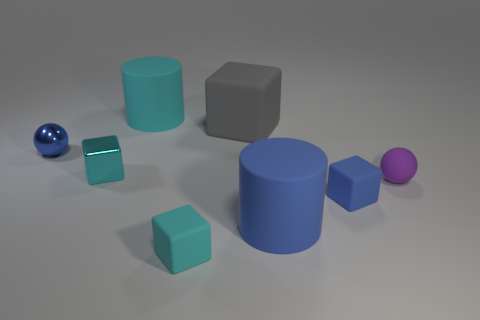Subtract all small cyan rubber cubes. How many cubes are left? 3 Subtract all purple spheres. How many spheres are left? 1 Add 1 purple metallic cylinders. How many objects exist? 9 Subtract 1 balls. How many balls are left? 1 Subtract all cylinders. How many objects are left? 6 Subtract all purple balls. How many cyan cubes are left? 2 Subtract all large purple matte spheres. Subtract all tiny blue blocks. How many objects are left? 7 Add 6 tiny blue balls. How many tiny blue balls are left? 7 Add 2 large blue shiny objects. How many large blue shiny objects exist? 2 Subtract 1 blue cylinders. How many objects are left? 7 